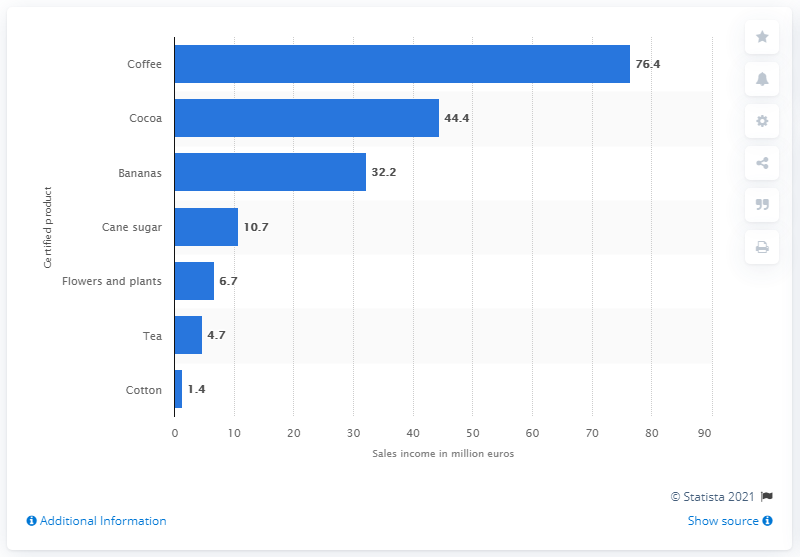Identify some key points in this picture. According to the data provided, the global sales income of certified Fairtrade International coffee in 2018 was 76.4 million US dollars. 